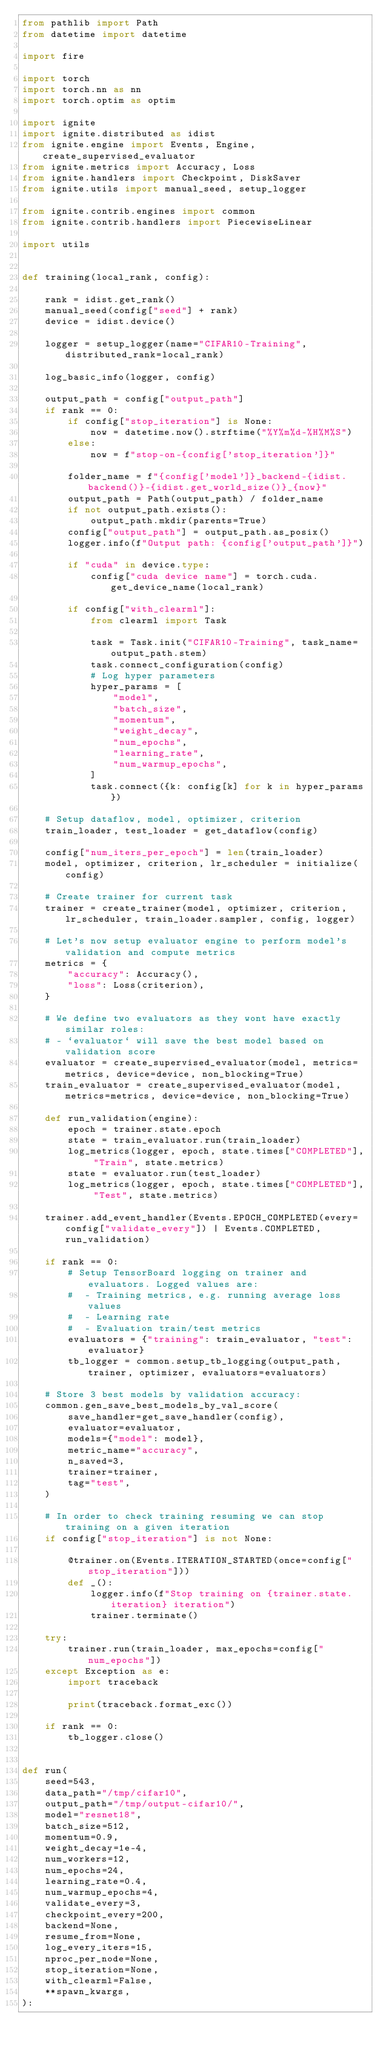<code> <loc_0><loc_0><loc_500><loc_500><_Python_>from pathlib import Path
from datetime import datetime

import fire

import torch
import torch.nn as nn
import torch.optim as optim

import ignite
import ignite.distributed as idist
from ignite.engine import Events, Engine, create_supervised_evaluator
from ignite.metrics import Accuracy, Loss
from ignite.handlers import Checkpoint, DiskSaver
from ignite.utils import manual_seed, setup_logger

from ignite.contrib.engines import common
from ignite.contrib.handlers import PiecewiseLinear

import utils


def training(local_rank, config):

    rank = idist.get_rank()
    manual_seed(config["seed"] + rank)
    device = idist.device()

    logger = setup_logger(name="CIFAR10-Training", distributed_rank=local_rank)

    log_basic_info(logger, config)

    output_path = config["output_path"]
    if rank == 0:
        if config["stop_iteration"] is None:
            now = datetime.now().strftime("%Y%m%d-%H%M%S")
        else:
            now = f"stop-on-{config['stop_iteration']}"

        folder_name = f"{config['model']}_backend-{idist.backend()}-{idist.get_world_size()}_{now}"
        output_path = Path(output_path) / folder_name
        if not output_path.exists():
            output_path.mkdir(parents=True)
        config["output_path"] = output_path.as_posix()
        logger.info(f"Output path: {config['output_path']}")

        if "cuda" in device.type:
            config["cuda device name"] = torch.cuda.get_device_name(local_rank)

        if config["with_clearml"]:
            from clearml import Task

            task = Task.init("CIFAR10-Training", task_name=output_path.stem)
            task.connect_configuration(config)
            # Log hyper parameters
            hyper_params = [
                "model",
                "batch_size",
                "momentum",
                "weight_decay",
                "num_epochs",
                "learning_rate",
                "num_warmup_epochs",
            ]
            task.connect({k: config[k] for k in hyper_params})

    # Setup dataflow, model, optimizer, criterion
    train_loader, test_loader = get_dataflow(config)

    config["num_iters_per_epoch"] = len(train_loader)
    model, optimizer, criterion, lr_scheduler = initialize(config)

    # Create trainer for current task
    trainer = create_trainer(model, optimizer, criterion, lr_scheduler, train_loader.sampler, config, logger)

    # Let's now setup evaluator engine to perform model's validation and compute metrics
    metrics = {
        "accuracy": Accuracy(),
        "loss": Loss(criterion),
    }

    # We define two evaluators as they wont have exactly similar roles:
    # - `evaluator` will save the best model based on validation score
    evaluator = create_supervised_evaluator(model, metrics=metrics, device=device, non_blocking=True)
    train_evaluator = create_supervised_evaluator(model, metrics=metrics, device=device, non_blocking=True)

    def run_validation(engine):
        epoch = trainer.state.epoch
        state = train_evaluator.run(train_loader)
        log_metrics(logger, epoch, state.times["COMPLETED"], "Train", state.metrics)
        state = evaluator.run(test_loader)
        log_metrics(logger, epoch, state.times["COMPLETED"], "Test", state.metrics)

    trainer.add_event_handler(Events.EPOCH_COMPLETED(every=config["validate_every"]) | Events.COMPLETED, run_validation)

    if rank == 0:
        # Setup TensorBoard logging on trainer and evaluators. Logged values are:
        #  - Training metrics, e.g. running average loss values
        #  - Learning rate
        #  - Evaluation train/test metrics
        evaluators = {"training": train_evaluator, "test": evaluator}
        tb_logger = common.setup_tb_logging(output_path, trainer, optimizer, evaluators=evaluators)

    # Store 3 best models by validation accuracy:
    common.gen_save_best_models_by_val_score(
        save_handler=get_save_handler(config),
        evaluator=evaluator,
        models={"model": model},
        metric_name="accuracy",
        n_saved=3,
        trainer=trainer,
        tag="test",
    )

    # In order to check training resuming we can stop training on a given iteration
    if config["stop_iteration"] is not None:

        @trainer.on(Events.ITERATION_STARTED(once=config["stop_iteration"]))
        def _():
            logger.info(f"Stop training on {trainer.state.iteration} iteration")
            trainer.terminate()

    try:
        trainer.run(train_loader, max_epochs=config["num_epochs"])
    except Exception as e:
        import traceback

        print(traceback.format_exc())

    if rank == 0:
        tb_logger.close()


def run(
    seed=543,
    data_path="/tmp/cifar10",
    output_path="/tmp/output-cifar10/",
    model="resnet18",
    batch_size=512,
    momentum=0.9,
    weight_decay=1e-4,
    num_workers=12,
    num_epochs=24,
    learning_rate=0.4,
    num_warmup_epochs=4,
    validate_every=3,
    checkpoint_every=200,
    backend=None,
    resume_from=None,
    log_every_iters=15,
    nproc_per_node=None,
    stop_iteration=None,
    with_clearml=False,
    **spawn_kwargs,
):</code> 